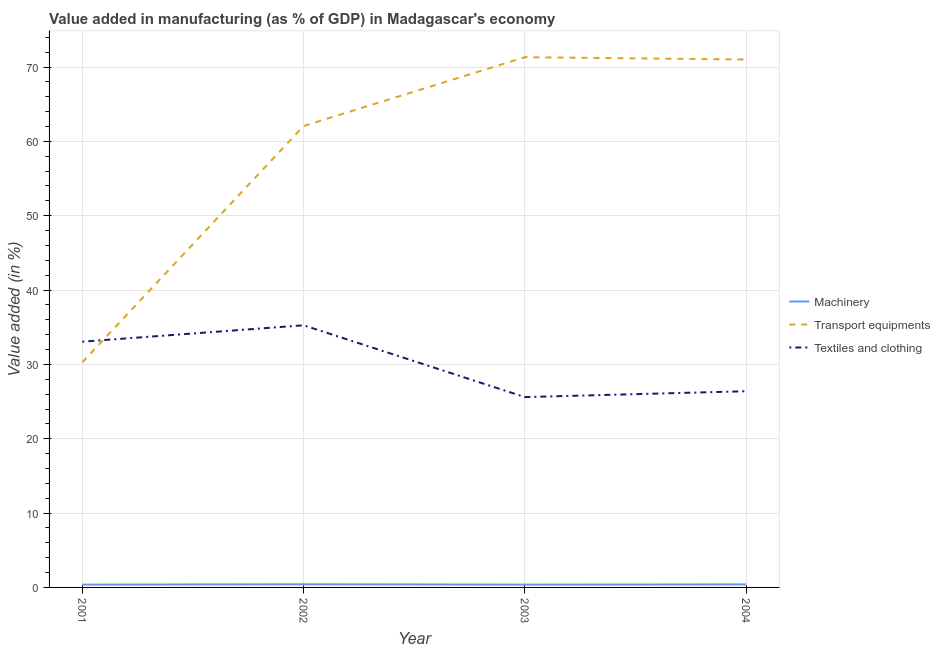How many different coloured lines are there?
Your answer should be compact. 3. What is the value added in manufacturing textile and clothing in 2001?
Offer a very short reply. 33.06. Across all years, what is the maximum value added in manufacturing transport equipments?
Offer a very short reply. 71.33. Across all years, what is the minimum value added in manufacturing machinery?
Your answer should be compact. 0.38. In which year was the value added in manufacturing machinery maximum?
Your answer should be compact. 2002. In which year was the value added in manufacturing machinery minimum?
Offer a very short reply. 2001. What is the total value added in manufacturing textile and clothing in the graph?
Make the answer very short. 120.32. What is the difference between the value added in manufacturing machinery in 2001 and that in 2002?
Offer a very short reply. -0.04. What is the difference between the value added in manufacturing transport equipments in 2001 and the value added in manufacturing textile and clothing in 2003?
Your answer should be very brief. 4.68. What is the average value added in manufacturing machinery per year?
Ensure brevity in your answer.  0.39. In the year 2002, what is the difference between the value added in manufacturing transport equipments and value added in manufacturing textile and clothing?
Provide a succinct answer. 26.81. What is the ratio of the value added in manufacturing textile and clothing in 2001 to that in 2002?
Keep it short and to the point. 0.94. Is the value added in manufacturing machinery in 2002 less than that in 2003?
Your response must be concise. No. Is the difference between the value added in manufacturing machinery in 2001 and 2004 greater than the difference between the value added in manufacturing textile and clothing in 2001 and 2004?
Offer a very short reply. No. What is the difference between the highest and the second highest value added in manufacturing textile and clothing?
Provide a succinct answer. 2.2. What is the difference between the highest and the lowest value added in manufacturing machinery?
Keep it short and to the point. 0.04. Is it the case that in every year, the sum of the value added in manufacturing machinery and value added in manufacturing transport equipments is greater than the value added in manufacturing textile and clothing?
Your response must be concise. No. Does the value added in manufacturing machinery monotonically increase over the years?
Your answer should be compact. No. Is the value added in manufacturing transport equipments strictly greater than the value added in manufacturing machinery over the years?
Make the answer very short. Yes. How many years are there in the graph?
Your answer should be very brief. 4. What is the difference between two consecutive major ticks on the Y-axis?
Make the answer very short. 10. Are the values on the major ticks of Y-axis written in scientific E-notation?
Give a very brief answer. No. Does the graph contain any zero values?
Your answer should be very brief. No. How many legend labels are there?
Provide a succinct answer. 3. How are the legend labels stacked?
Your response must be concise. Vertical. What is the title of the graph?
Your response must be concise. Value added in manufacturing (as % of GDP) in Madagascar's economy. What is the label or title of the X-axis?
Offer a terse response. Year. What is the label or title of the Y-axis?
Your answer should be very brief. Value added (in %). What is the Value added (in %) of Machinery in 2001?
Provide a short and direct response. 0.38. What is the Value added (in %) in Transport equipments in 2001?
Give a very brief answer. 30.29. What is the Value added (in %) of Textiles and clothing in 2001?
Your answer should be very brief. 33.06. What is the Value added (in %) in Machinery in 2002?
Provide a short and direct response. 0.42. What is the Value added (in %) in Transport equipments in 2002?
Your response must be concise. 62.07. What is the Value added (in %) in Textiles and clothing in 2002?
Keep it short and to the point. 35.26. What is the Value added (in %) of Machinery in 2003?
Provide a short and direct response. 0.38. What is the Value added (in %) of Transport equipments in 2003?
Provide a succinct answer. 71.33. What is the Value added (in %) in Textiles and clothing in 2003?
Offer a very short reply. 25.61. What is the Value added (in %) in Machinery in 2004?
Ensure brevity in your answer.  0.4. What is the Value added (in %) of Transport equipments in 2004?
Offer a terse response. 71.01. What is the Value added (in %) in Textiles and clothing in 2004?
Keep it short and to the point. 26.39. Across all years, what is the maximum Value added (in %) of Machinery?
Provide a short and direct response. 0.42. Across all years, what is the maximum Value added (in %) in Transport equipments?
Keep it short and to the point. 71.33. Across all years, what is the maximum Value added (in %) in Textiles and clothing?
Offer a very short reply. 35.26. Across all years, what is the minimum Value added (in %) of Machinery?
Make the answer very short. 0.38. Across all years, what is the minimum Value added (in %) in Transport equipments?
Offer a terse response. 30.29. Across all years, what is the minimum Value added (in %) of Textiles and clothing?
Keep it short and to the point. 25.61. What is the total Value added (in %) of Machinery in the graph?
Your response must be concise. 1.57. What is the total Value added (in %) in Transport equipments in the graph?
Keep it short and to the point. 234.7. What is the total Value added (in %) in Textiles and clothing in the graph?
Your response must be concise. 120.32. What is the difference between the Value added (in %) in Machinery in 2001 and that in 2002?
Ensure brevity in your answer.  -0.04. What is the difference between the Value added (in %) of Transport equipments in 2001 and that in 2002?
Your answer should be very brief. -31.79. What is the difference between the Value added (in %) in Textiles and clothing in 2001 and that in 2002?
Keep it short and to the point. -2.2. What is the difference between the Value added (in %) of Machinery in 2001 and that in 2003?
Provide a succinct answer. -0. What is the difference between the Value added (in %) in Transport equipments in 2001 and that in 2003?
Your answer should be very brief. -41.04. What is the difference between the Value added (in %) in Textiles and clothing in 2001 and that in 2003?
Your answer should be very brief. 7.45. What is the difference between the Value added (in %) in Machinery in 2001 and that in 2004?
Provide a short and direct response. -0.03. What is the difference between the Value added (in %) in Transport equipments in 2001 and that in 2004?
Offer a terse response. -40.73. What is the difference between the Value added (in %) in Textiles and clothing in 2001 and that in 2004?
Offer a very short reply. 6.67. What is the difference between the Value added (in %) in Machinery in 2002 and that in 2003?
Your answer should be very brief. 0.04. What is the difference between the Value added (in %) of Transport equipments in 2002 and that in 2003?
Offer a very short reply. -9.25. What is the difference between the Value added (in %) of Textiles and clothing in 2002 and that in 2003?
Provide a short and direct response. 9.66. What is the difference between the Value added (in %) of Machinery in 2002 and that in 2004?
Your answer should be compact. 0.02. What is the difference between the Value added (in %) in Transport equipments in 2002 and that in 2004?
Offer a very short reply. -8.94. What is the difference between the Value added (in %) of Textiles and clothing in 2002 and that in 2004?
Offer a terse response. 8.87. What is the difference between the Value added (in %) of Machinery in 2003 and that in 2004?
Provide a short and direct response. -0.02. What is the difference between the Value added (in %) in Transport equipments in 2003 and that in 2004?
Keep it short and to the point. 0.31. What is the difference between the Value added (in %) in Textiles and clothing in 2003 and that in 2004?
Your response must be concise. -0.79. What is the difference between the Value added (in %) in Machinery in 2001 and the Value added (in %) in Transport equipments in 2002?
Provide a succinct answer. -61.7. What is the difference between the Value added (in %) of Machinery in 2001 and the Value added (in %) of Textiles and clothing in 2002?
Give a very brief answer. -34.89. What is the difference between the Value added (in %) of Transport equipments in 2001 and the Value added (in %) of Textiles and clothing in 2002?
Offer a terse response. -4.98. What is the difference between the Value added (in %) of Machinery in 2001 and the Value added (in %) of Transport equipments in 2003?
Provide a succinct answer. -70.95. What is the difference between the Value added (in %) of Machinery in 2001 and the Value added (in %) of Textiles and clothing in 2003?
Offer a terse response. -25.23. What is the difference between the Value added (in %) in Transport equipments in 2001 and the Value added (in %) in Textiles and clothing in 2003?
Your answer should be compact. 4.68. What is the difference between the Value added (in %) in Machinery in 2001 and the Value added (in %) in Transport equipments in 2004?
Your response must be concise. -70.64. What is the difference between the Value added (in %) of Machinery in 2001 and the Value added (in %) of Textiles and clothing in 2004?
Give a very brief answer. -26.02. What is the difference between the Value added (in %) of Transport equipments in 2001 and the Value added (in %) of Textiles and clothing in 2004?
Make the answer very short. 3.9. What is the difference between the Value added (in %) in Machinery in 2002 and the Value added (in %) in Transport equipments in 2003?
Offer a terse response. -70.91. What is the difference between the Value added (in %) of Machinery in 2002 and the Value added (in %) of Textiles and clothing in 2003?
Provide a short and direct response. -25.19. What is the difference between the Value added (in %) in Transport equipments in 2002 and the Value added (in %) in Textiles and clothing in 2003?
Give a very brief answer. 36.47. What is the difference between the Value added (in %) in Machinery in 2002 and the Value added (in %) in Transport equipments in 2004?
Provide a succinct answer. -70.59. What is the difference between the Value added (in %) in Machinery in 2002 and the Value added (in %) in Textiles and clothing in 2004?
Keep it short and to the point. -25.97. What is the difference between the Value added (in %) in Transport equipments in 2002 and the Value added (in %) in Textiles and clothing in 2004?
Provide a succinct answer. 35.68. What is the difference between the Value added (in %) in Machinery in 2003 and the Value added (in %) in Transport equipments in 2004?
Provide a short and direct response. -70.64. What is the difference between the Value added (in %) of Machinery in 2003 and the Value added (in %) of Textiles and clothing in 2004?
Your response must be concise. -26.01. What is the difference between the Value added (in %) in Transport equipments in 2003 and the Value added (in %) in Textiles and clothing in 2004?
Your answer should be very brief. 44.93. What is the average Value added (in %) of Machinery per year?
Keep it short and to the point. 0.39. What is the average Value added (in %) in Transport equipments per year?
Give a very brief answer. 58.67. What is the average Value added (in %) of Textiles and clothing per year?
Your answer should be compact. 30.08. In the year 2001, what is the difference between the Value added (in %) in Machinery and Value added (in %) in Transport equipments?
Offer a terse response. -29.91. In the year 2001, what is the difference between the Value added (in %) of Machinery and Value added (in %) of Textiles and clothing?
Your answer should be compact. -32.68. In the year 2001, what is the difference between the Value added (in %) in Transport equipments and Value added (in %) in Textiles and clothing?
Offer a terse response. -2.77. In the year 2002, what is the difference between the Value added (in %) of Machinery and Value added (in %) of Transport equipments?
Your answer should be very brief. -61.65. In the year 2002, what is the difference between the Value added (in %) of Machinery and Value added (in %) of Textiles and clothing?
Offer a very short reply. -34.84. In the year 2002, what is the difference between the Value added (in %) of Transport equipments and Value added (in %) of Textiles and clothing?
Your answer should be very brief. 26.81. In the year 2003, what is the difference between the Value added (in %) of Machinery and Value added (in %) of Transport equipments?
Make the answer very short. -70.95. In the year 2003, what is the difference between the Value added (in %) of Machinery and Value added (in %) of Textiles and clothing?
Provide a succinct answer. -25.23. In the year 2003, what is the difference between the Value added (in %) of Transport equipments and Value added (in %) of Textiles and clothing?
Ensure brevity in your answer.  45.72. In the year 2004, what is the difference between the Value added (in %) of Machinery and Value added (in %) of Transport equipments?
Provide a short and direct response. -70.61. In the year 2004, what is the difference between the Value added (in %) in Machinery and Value added (in %) in Textiles and clothing?
Offer a very short reply. -25.99. In the year 2004, what is the difference between the Value added (in %) of Transport equipments and Value added (in %) of Textiles and clothing?
Ensure brevity in your answer.  44.62. What is the ratio of the Value added (in %) of Machinery in 2001 to that in 2002?
Make the answer very short. 0.9. What is the ratio of the Value added (in %) of Transport equipments in 2001 to that in 2002?
Your response must be concise. 0.49. What is the ratio of the Value added (in %) in Machinery in 2001 to that in 2003?
Give a very brief answer. 0.99. What is the ratio of the Value added (in %) of Transport equipments in 2001 to that in 2003?
Your answer should be compact. 0.42. What is the ratio of the Value added (in %) in Textiles and clothing in 2001 to that in 2003?
Your answer should be compact. 1.29. What is the ratio of the Value added (in %) of Machinery in 2001 to that in 2004?
Offer a very short reply. 0.94. What is the ratio of the Value added (in %) of Transport equipments in 2001 to that in 2004?
Your answer should be compact. 0.43. What is the ratio of the Value added (in %) in Textiles and clothing in 2001 to that in 2004?
Offer a very short reply. 1.25. What is the ratio of the Value added (in %) of Machinery in 2002 to that in 2003?
Your answer should be compact. 1.11. What is the ratio of the Value added (in %) of Transport equipments in 2002 to that in 2003?
Provide a succinct answer. 0.87. What is the ratio of the Value added (in %) in Textiles and clothing in 2002 to that in 2003?
Keep it short and to the point. 1.38. What is the ratio of the Value added (in %) in Machinery in 2002 to that in 2004?
Provide a short and direct response. 1.05. What is the ratio of the Value added (in %) in Transport equipments in 2002 to that in 2004?
Ensure brevity in your answer.  0.87. What is the ratio of the Value added (in %) of Textiles and clothing in 2002 to that in 2004?
Make the answer very short. 1.34. What is the ratio of the Value added (in %) of Machinery in 2003 to that in 2004?
Keep it short and to the point. 0.94. What is the ratio of the Value added (in %) of Textiles and clothing in 2003 to that in 2004?
Your answer should be compact. 0.97. What is the difference between the highest and the second highest Value added (in %) of Machinery?
Your response must be concise. 0.02. What is the difference between the highest and the second highest Value added (in %) in Transport equipments?
Your answer should be compact. 0.31. What is the difference between the highest and the second highest Value added (in %) of Textiles and clothing?
Offer a terse response. 2.2. What is the difference between the highest and the lowest Value added (in %) in Machinery?
Your response must be concise. 0.04. What is the difference between the highest and the lowest Value added (in %) in Transport equipments?
Make the answer very short. 41.04. What is the difference between the highest and the lowest Value added (in %) of Textiles and clothing?
Your answer should be compact. 9.66. 